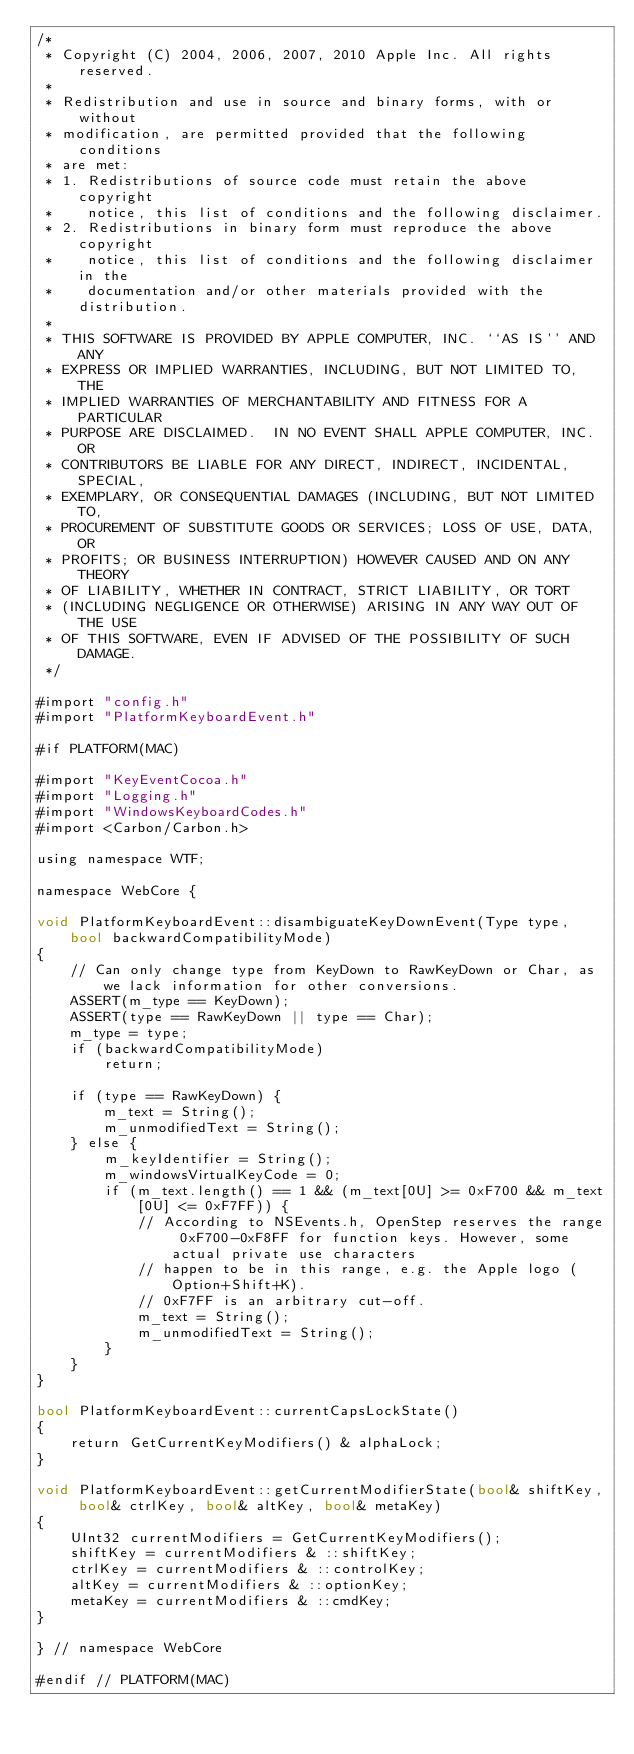Convert code to text. <code><loc_0><loc_0><loc_500><loc_500><_ObjectiveC_>/*
 * Copyright (C) 2004, 2006, 2007, 2010 Apple Inc. All rights reserved.
 *
 * Redistribution and use in source and binary forms, with or without
 * modification, are permitted provided that the following conditions
 * are met:
 * 1. Redistributions of source code must retain the above copyright
 *    notice, this list of conditions and the following disclaimer.
 * 2. Redistributions in binary form must reproduce the above copyright
 *    notice, this list of conditions and the following disclaimer in the
 *    documentation and/or other materials provided with the distribution.
 *
 * THIS SOFTWARE IS PROVIDED BY APPLE COMPUTER, INC. ``AS IS'' AND ANY
 * EXPRESS OR IMPLIED WARRANTIES, INCLUDING, BUT NOT LIMITED TO, THE
 * IMPLIED WARRANTIES OF MERCHANTABILITY AND FITNESS FOR A PARTICULAR
 * PURPOSE ARE DISCLAIMED.  IN NO EVENT SHALL APPLE COMPUTER, INC. OR
 * CONTRIBUTORS BE LIABLE FOR ANY DIRECT, INDIRECT, INCIDENTAL, SPECIAL,
 * EXEMPLARY, OR CONSEQUENTIAL DAMAGES (INCLUDING, BUT NOT LIMITED TO,
 * PROCUREMENT OF SUBSTITUTE GOODS OR SERVICES; LOSS OF USE, DATA, OR
 * PROFITS; OR BUSINESS INTERRUPTION) HOWEVER CAUSED AND ON ANY THEORY
 * OF LIABILITY, WHETHER IN CONTRACT, STRICT LIABILITY, OR TORT
 * (INCLUDING NEGLIGENCE OR OTHERWISE) ARISING IN ANY WAY OUT OF THE USE
 * OF THIS SOFTWARE, EVEN IF ADVISED OF THE POSSIBILITY OF SUCH DAMAGE.
 */

#import "config.h"
#import "PlatformKeyboardEvent.h"

#if PLATFORM(MAC)

#import "KeyEventCocoa.h"
#import "Logging.h"
#import "WindowsKeyboardCodes.h"
#import <Carbon/Carbon.h>

using namespace WTF;

namespace WebCore {

void PlatformKeyboardEvent::disambiguateKeyDownEvent(Type type, bool backwardCompatibilityMode)
{
    // Can only change type from KeyDown to RawKeyDown or Char, as we lack information for other conversions.
    ASSERT(m_type == KeyDown);
    ASSERT(type == RawKeyDown || type == Char);
    m_type = type;
    if (backwardCompatibilityMode)
        return;

    if (type == RawKeyDown) {
        m_text = String();
        m_unmodifiedText = String();
    } else {
        m_keyIdentifier = String();
        m_windowsVirtualKeyCode = 0;
        if (m_text.length() == 1 && (m_text[0U] >= 0xF700 && m_text[0U] <= 0xF7FF)) {
            // According to NSEvents.h, OpenStep reserves the range 0xF700-0xF8FF for function keys. However, some actual private use characters
            // happen to be in this range, e.g. the Apple logo (Option+Shift+K).
            // 0xF7FF is an arbitrary cut-off.
            m_text = String();
            m_unmodifiedText = String();
        }
    }
}

bool PlatformKeyboardEvent::currentCapsLockState()
{
    return GetCurrentKeyModifiers() & alphaLock;
}

void PlatformKeyboardEvent::getCurrentModifierState(bool& shiftKey, bool& ctrlKey, bool& altKey, bool& metaKey)
{
    UInt32 currentModifiers = GetCurrentKeyModifiers();
    shiftKey = currentModifiers & ::shiftKey;
    ctrlKey = currentModifiers & ::controlKey;
    altKey = currentModifiers & ::optionKey;
    metaKey = currentModifiers & ::cmdKey;
}

} // namespace WebCore

#endif // PLATFORM(MAC)
</code> 